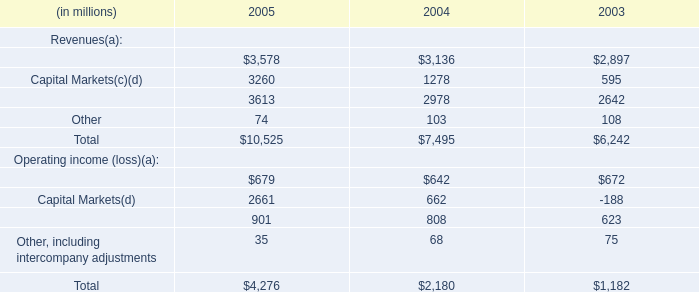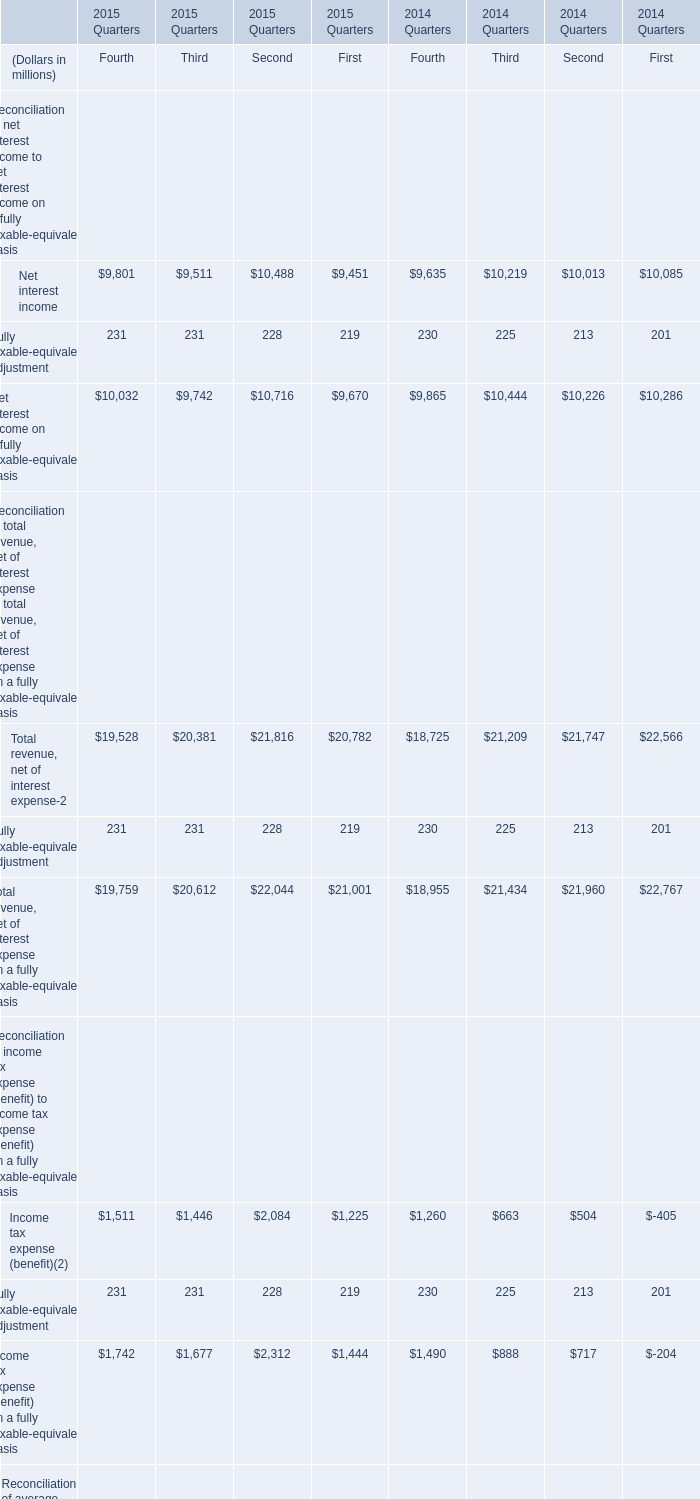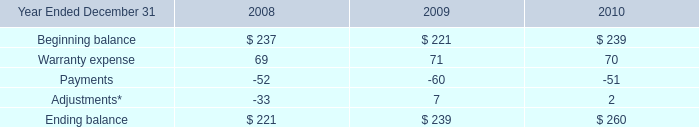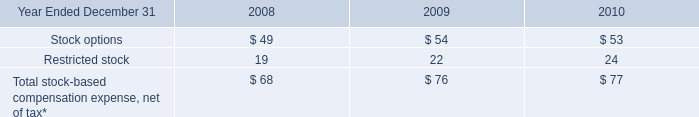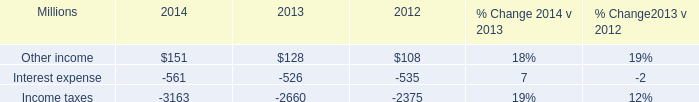How long does Fully taxable-equivalent adjustment keep growing for Fourth? 
Answer: 1. 